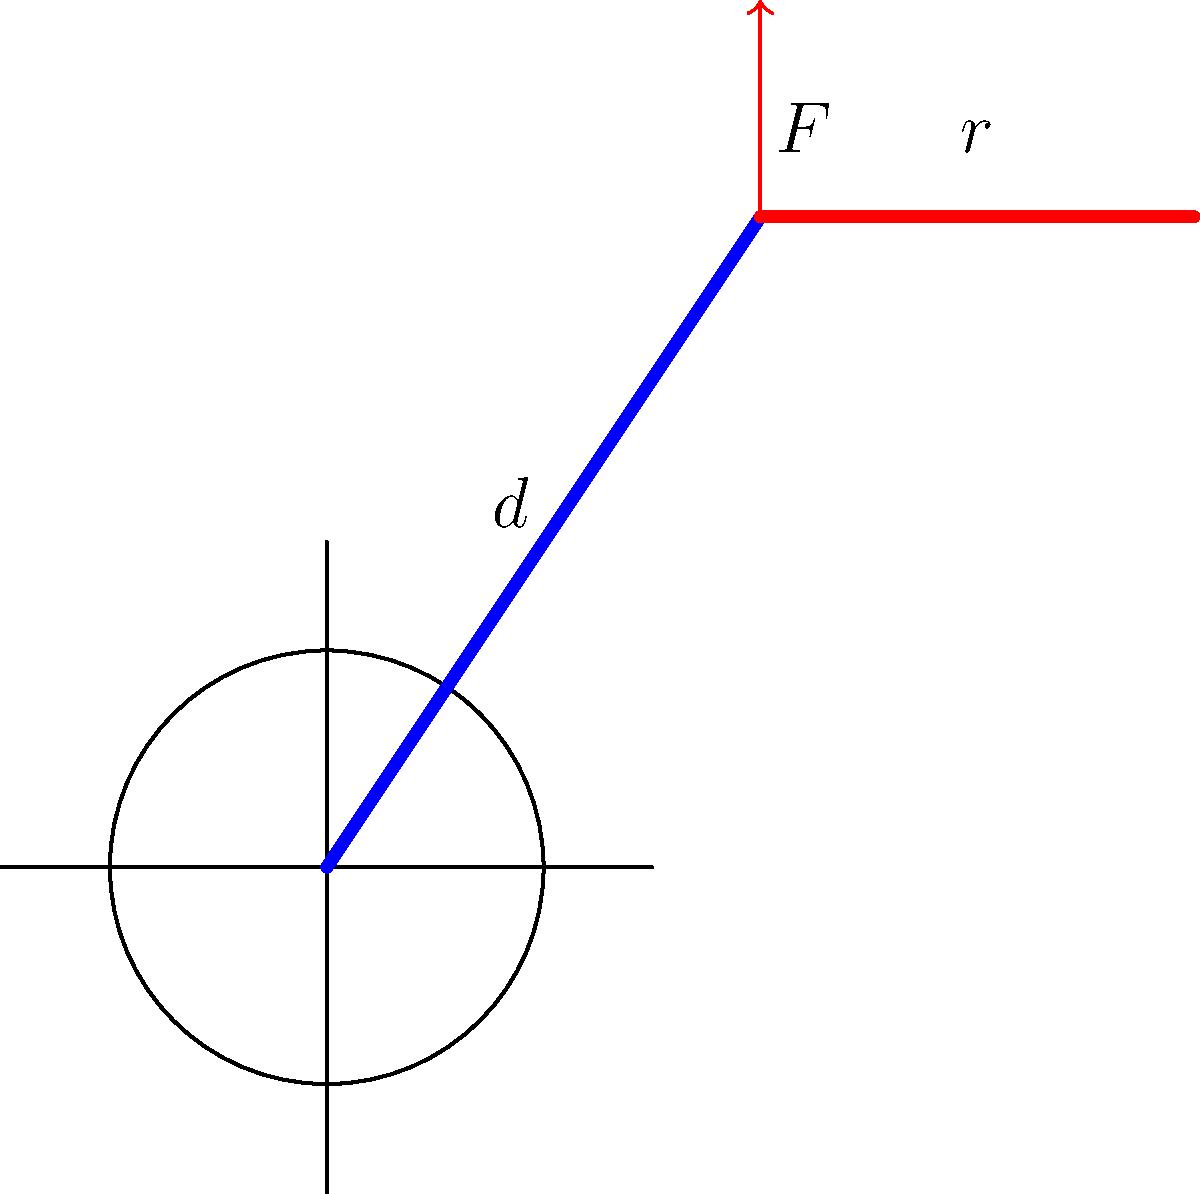A rehabilitation engineer is designing an adaptive lever mechanism for a wheelchair to assist patients with limited upper body strength. The mechanism uses a lever arm of length $d = 50$ cm attached to the wheelchair's axle. A force $F = 20$ N is applied at the end of the lever, and the wheel has a radius $r = 30$ cm. Calculate the torque applied to the wheel and explain how this design exemplifies the principle of mechanical advantage in adaptive equipment. To solve this problem and understand the mechanical advantage, let's follow these steps:

1) First, recall the formula for torque:
   $$\tau = F \times d$$
   where $\tau$ is torque, $F$ is force, and $d$ is the perpendicular distance from the axis of rotation to the line of action of the force.

2) In this case:
   $F = 20$ N
   $d = 50$ cm = 0.5 m

3) Calculate the torque:
   $$\tau = 20 \text{ N} \times 0.5 \text{ m} = 10 \text{ N}\cdot\text{m}$$

4) To understand the mechanical advantage, compare the force applied at the end of the lever to the force at the wheel:
   
   Force at wheel = Torque / Wheel radius
   $$F_w = \frac{\tau}{r} = \frac{10 \text{ N}\cdot\text{m}}{0.3 \text{ m}} = 33.33 \text{ N}$$

5) The mechanical advantage is the ratio of the output force to the input force:
   $$\text{MA} = \frac{F_w}{F} = \frac{33.33 \text{ N}}{20 \text{ N}} = 1.67$$

This design exemplifies the principle of mechanical advantage by allowing the patient to apply a smaller force over a longer distance to generate a larger force at the wheel. The longer lever arm (50 cm) compared to the wheel radius (30 cm) creates this advantage, making it easier for patients with limited strength to operate the wheelchair.
Answer: Torque = 10 N·m; Mechanical Advantage = 1.67 